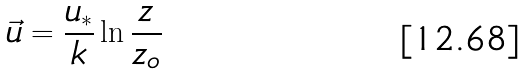<formula> <loc_0><loc_0><loc_500><loc_500>\vec { u } = \frac { u _ { * } } { k } \ln \frac { z } { z _ { o } }</formula> 